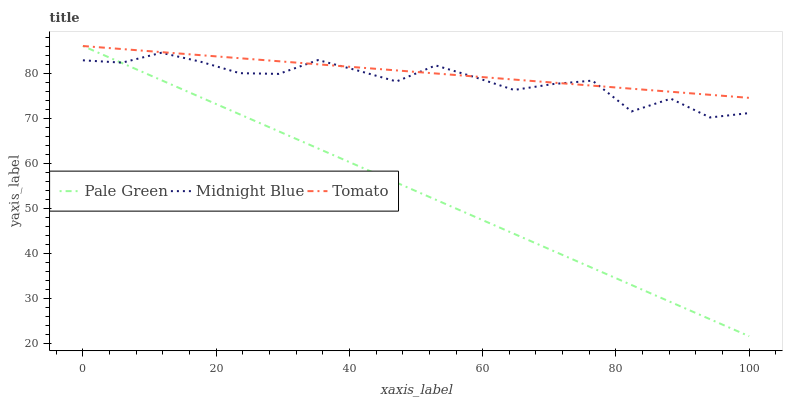Does Pale Green have the minimum area under the curve?
Answer yes or no. Yes. Does Tomato have the maximum area under the curve?
Answer yes or no. Yes. Does Midnight Blue have the minimum area under the curve?
Answer yes or no. No. Does Midnight Blue have the maximum area under the curve?
Answer yes or no. No. Is Pale Green the smoothest?
Answer yes or no. Yes. Is Midnight Blue the roughest?
Answer yes or no. Yes. Is Midnight Blue the smoothest?
Answer yes or no. No. Is Pale Green the roughest?
Answer yes or no. No. Does Pale Green have the lowest value?
Answer yes or no. Yes. Does Midnight Blue have the lowest value?
Answer yes or no. No. Does Pale Green have the highest value?
Answer yes or no. Yes. Does Midnight Blue have the highest value?
Answer yes or no. No. Does Pale Green intersect Tomato?
Answer yes or no. Yes. Is Pale Green less than Tomato?
Answer yes or no. No. Is Pale Green greater than Tomato?
Answer yes or no. No. 